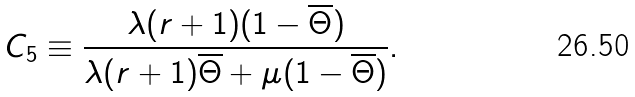<formula> <loc_0><loc_0><loc_500><loc_500>C _ { 5 } \equiv \frac { \lambda ( r + 1 ) ( 1 - \overline { \Theta } ) } { \lambda ( r + 1 ) \overline { \Theta } + \mu ( 1 - \overline { \Theta } ) } .</formula> 